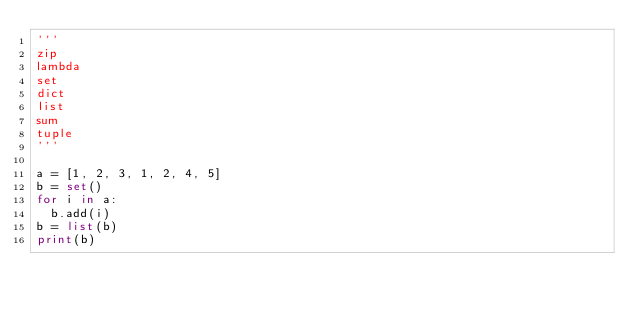Convert code to text. <code><loc_0><loc_0><loc_500><loc_500><_Python_>'''
zip
lambda
set
dict
list 
sum
tuple
'''

a = [1, 2, 3, 1, 2, 4, 5]
b = set()
for i in a:
	b.add(i)
b = list(b)
print(b)
</code> 